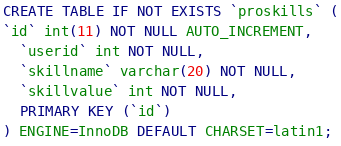Convert code to text. <code><loc_0><loc_0><loc_500><loc_500><_SQL_>
CREATE TABLE IF NOT EXISTS `proskills` (
`id` int(11) NOT NULL AUTO_INCREMENT,
  `userid` int NOT NULL,
  `skillname` varchar(20) NOT NULL,
  `skillvalue` int NOT NULL,
  PRIMARY KEY (`id`)
) ENGINE=InnoDB DEFAULT CHARSET=latin1;



</code> 